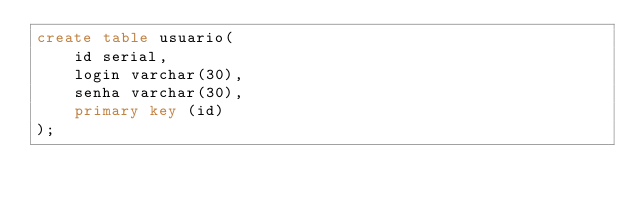Convert code to text. <code><loc_0><loc_0><loc_500><loc_500><_SQL_>create table usuario(
    id serial,
    login varchar(30),
    senha varchar(30),
    primary key (id)
);</code> 